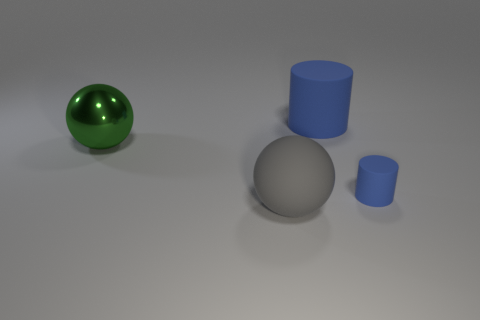Add 3 large purple metal objects. How many objects exist? 7 Add 2 large blue cubes. How many large blue cubes exist? 2 Subtract 0 blue spheres. How many objects are left? 4 Subtract all rubber spheres. Subtract all blue matte cubes. How many objects are left? 3 Add 3 large objects. How many large objects are left? 6 